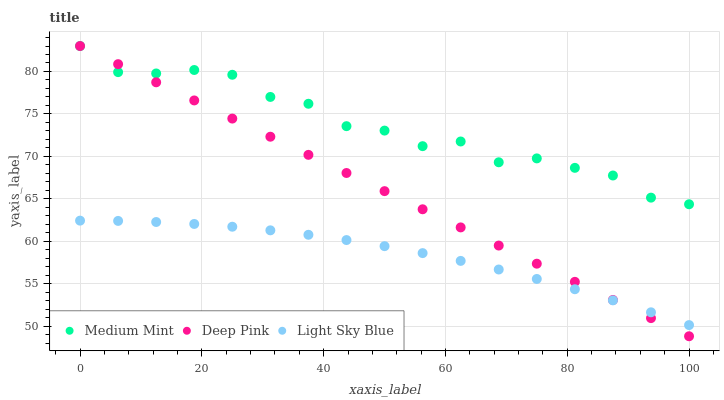Does Light Sky Blue have the minimum area under the curve?
Answer yes or no. Yes. Does Medium Mint have the maximum area under the curve?
Answer yes or no. Yes. Does Deep Pink have the minimum area under the curve?
Answer yes or no. No. Does Deep Pink have the maximum area under the curve?
Answer yes or no. No. Is Deep Pink the smoothest?
Answer yes or no. Yes. Is Medium Mint the roughest?
Answer yes or no. Yes. Is Light Sky Blue the smoothest?
Answer yes or no. No. Is Light Sky Blue the roughest?
Answer yes or no. No. Does Deep Pink have the lowest value?
Answer yes or no. Yes. Does Light Sky Blue have the lowest value?
Answer yes or no. No. Does Deep Pink have the highest value?
Answer yes or no. Yes. Does Light Sky Blue have the highest value?
Answer yes or no. No. Is Light Sky Blue less than Medium Mint?
Answer yes or no. Yes. Is Medium Mint greater than Light Sky Blue?
Answer yes or no. Yes. Does Medium Mint intersect Deep Pink?
Answer yes or no. Yes. Is Medium Mint less than Deep Pink?
Answer yes or no. No. Is Medium Mint greater than Deep Pink?
Answer yes or no. No. Does Light Sky Blue intersect Medium Mint?
Answer yes or no. No. 